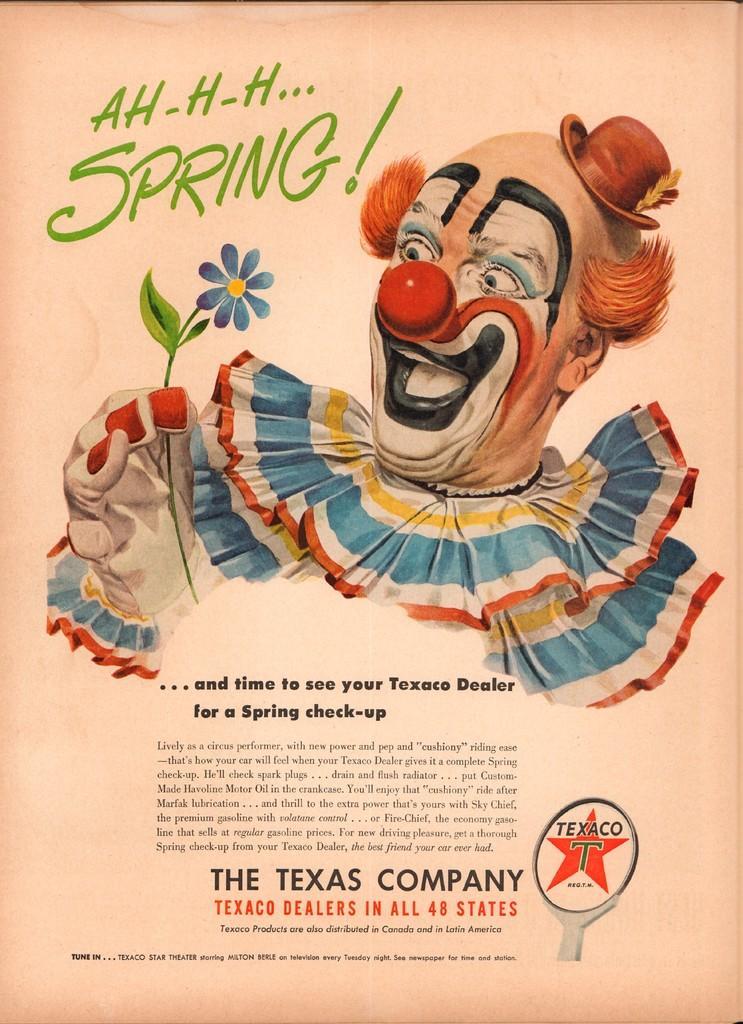Could you give a brief overview of what you see in this image? This is a zoomed in picture. In the center there is a clown holding a flower and we can see the text is written on the image. 